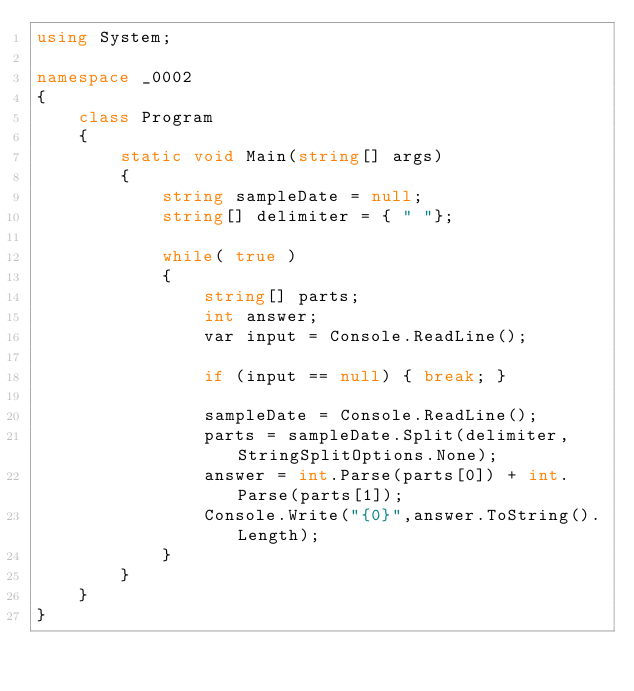Convert code to text. <code><loc_0><loc_0><loc_500><loc_500><_C#_>using System;

namespace _0002
{
    class Program
    {
        static void Main(string[] args)
        {
            string sampleDate = null;
            string[] delimiter = { " "};

            while( true )
            {
                string[] parts;
                int answer;
                var input = Console.ReadLine();

                if (input == null) { break; }

                sampleDate = Console.ReadLine();
                parts = sampleDate.Split(delimiter, StringSplitOptions.None);
                answer = int.Parse(parts[0]) + int.Parse(parts[1]);
                Console.Write("{0}",answer.ToString().Length);
            }
        }
    }
}</code> 